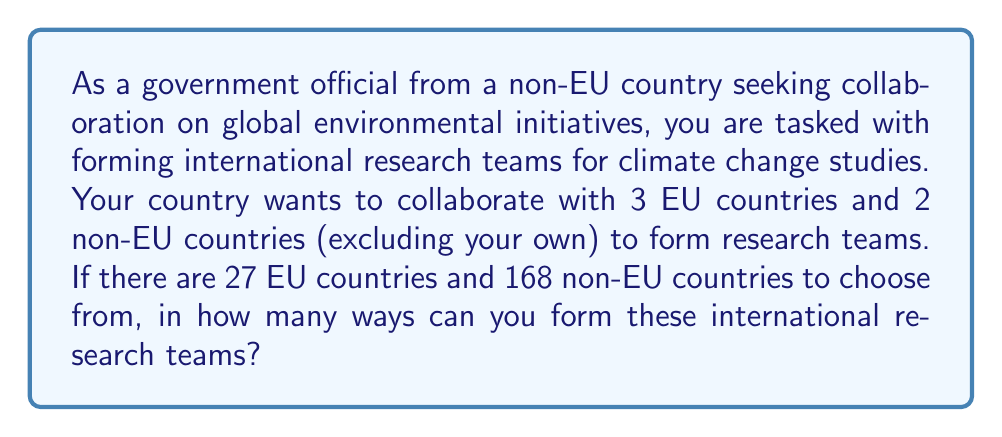What is the answer to this math problem? To solve this problem, we need to use the combination formula. We will select countries independently from two groups: EU countries and non-EU countries.

1. Selecting EU countries:
   We need to choose 3 EU countries out of 27.
   This can be done in $\binom{27}{3}$ ways.
   
   $$\binom{27}{3} = \frac{27!}{3!(27-3)!} = \frac{27!}{3!24!} = 2925$$

2. Selecting non-EU countries:
   We need to choose 2 non-EU countries out of 168 (excluding our own country).
   This can be done in $\binom{168}{2}$ ways.
   
   $$\binom{168}{2} = \frac{168!}{2!(168-2)!} = \frac{168!}{2!166!} = 14028$$

3. By the multiplication principle, the total number of ways to form these international research teams is the product of the number of ways to select EU countries and the number of ways to select non-EU countries.

   Total number of ways = $2925 \times 14028$

4. Calculating the final result:
   $2925 \times 14028 = 41,031,900$
Answer: The number of ways to form international research teams for climate change studies is 41,031,900. 